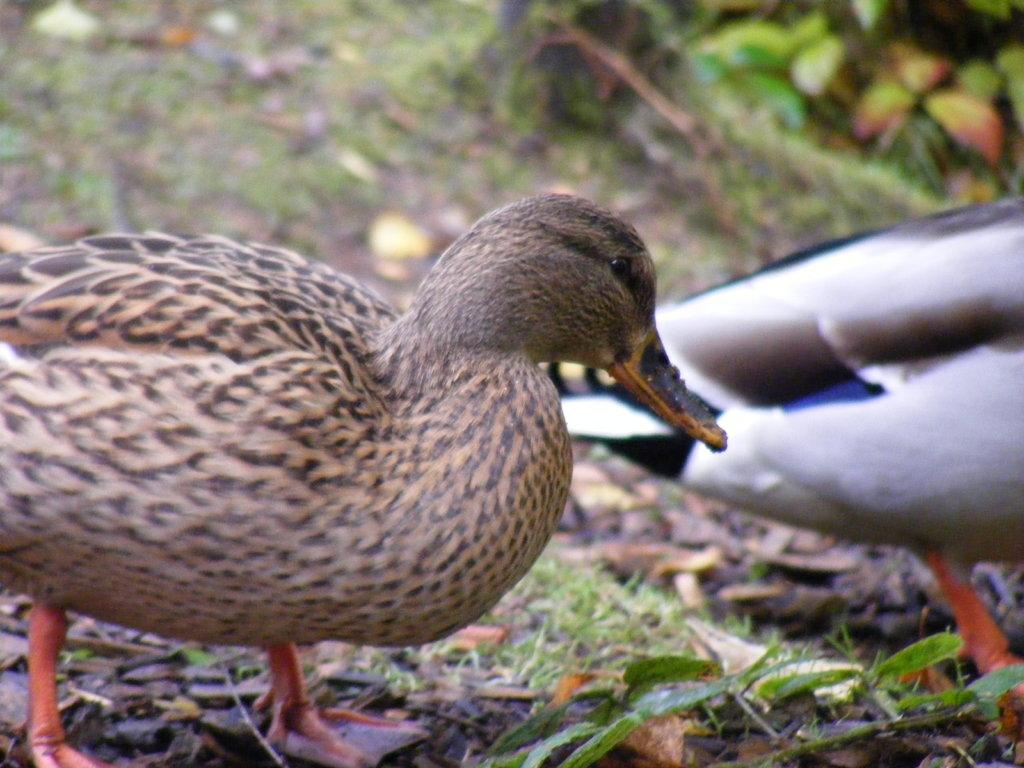What animals are present in the image? There are two ducks in the image. Where are the ducks located? The ducks are on the ground. What color is the background of the image? The background of the image is blue. What type of dinner is being served in the image? There is no dinner present in the image; it features two ducks on the ground with a blue background. 